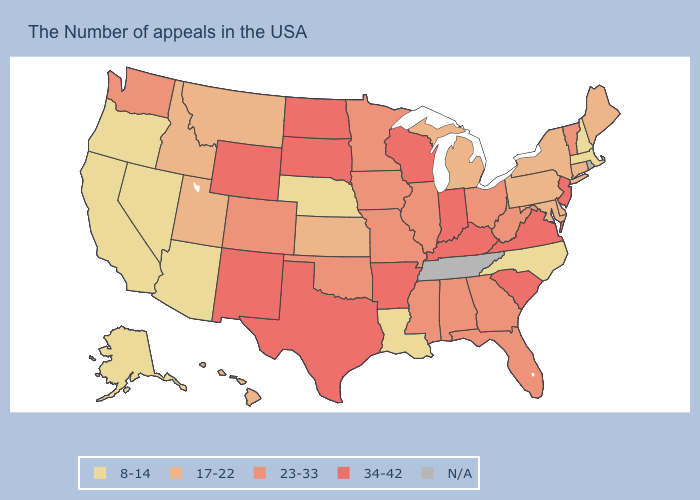What is the highest value in states that border Ohio?
Short answer required. 34-42. What is the value of Maryland?
Give a very brief answer. 17-22. Name the states that have a value in the range 17-22?
Quick response, please. Maine, Connecticut, New York, Delaware, Maryland, Pennsylvania, Michigan, Kansas, Utah, Montana, Idaho, Hawaii. Among the states that border North Dakota , does Montana have the lowest value?
Write a very short answer. Yes. What is the highest value in states that border Colorado?
Give a very brief answer. 34-42. Does Pennsylvania have the highest value in the USA?
Answer briefly. No. Does Wyoming have the highest value in the USA?
Be succinct. Yes. Name the states that have a value in the range N/A?
Be succinct. Rhode Island, Tennessee. Which states hav the highest value in the West?
Write a very short answer. Wyoming, New Mexico. What is the value of Massachusetts?
Quick response, please. 8-14. Which states hav the highest value in the MidWest?
Be succinct. Indiana, Wisconsin, South Dakota, North Dakota. Among the states that border Iowa , which have the lowest value?
Answer briefly. Nebraska. Among the states that border Virginia , does Maryland have the lowest value?
Quick response, please. No. What is the lowest value in the USA?
Keep it brief. 8-14. Does South Carolina have the highest value in the USA?
Quick response, please. Yes. 